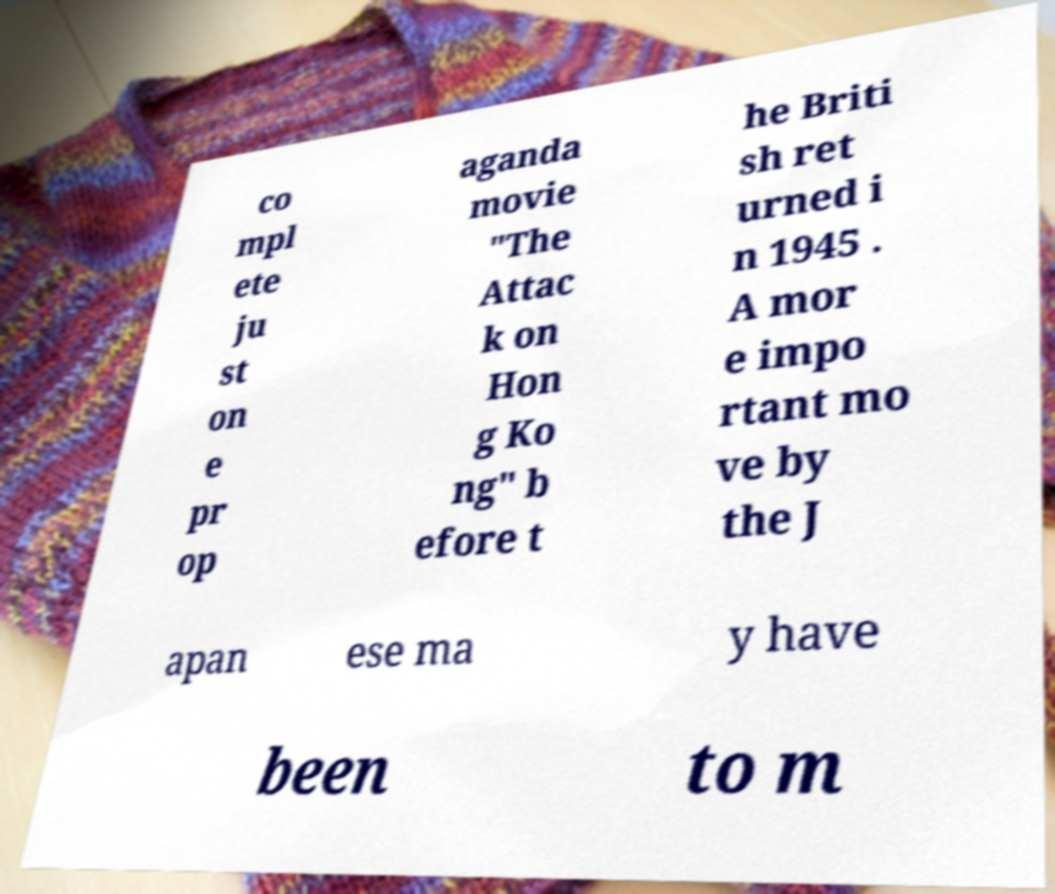Can you accurately transcribe the text from the provided image for me? co mpl ete ju st on e pr op aganda movie "The Attac k on Hon g Ko ng" b efore t he Briti sh ret urned i n 1945 . A mor e impo rtant mo ve by the J apan ese ma y have been to m 